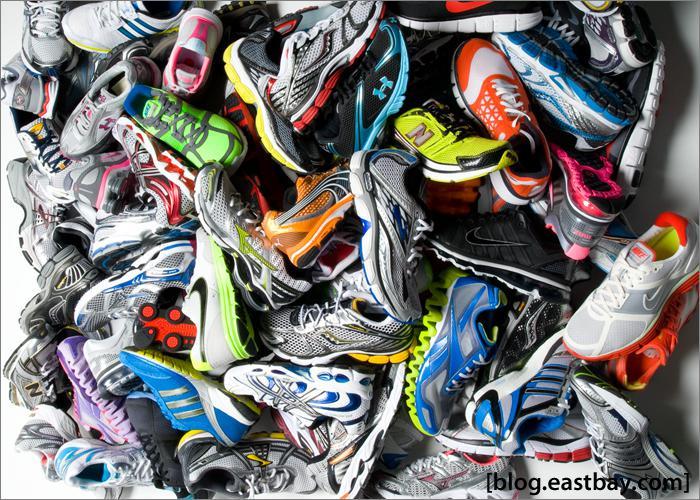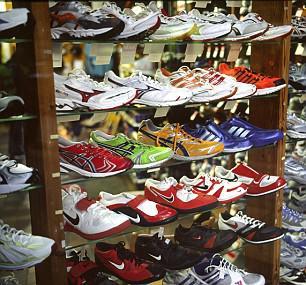The first image is the image on the left, the second image is the image on the right. For the images shown, is this caption "the shoes are piled loosely in one of the images" true? Answer yes or no. Yes. 